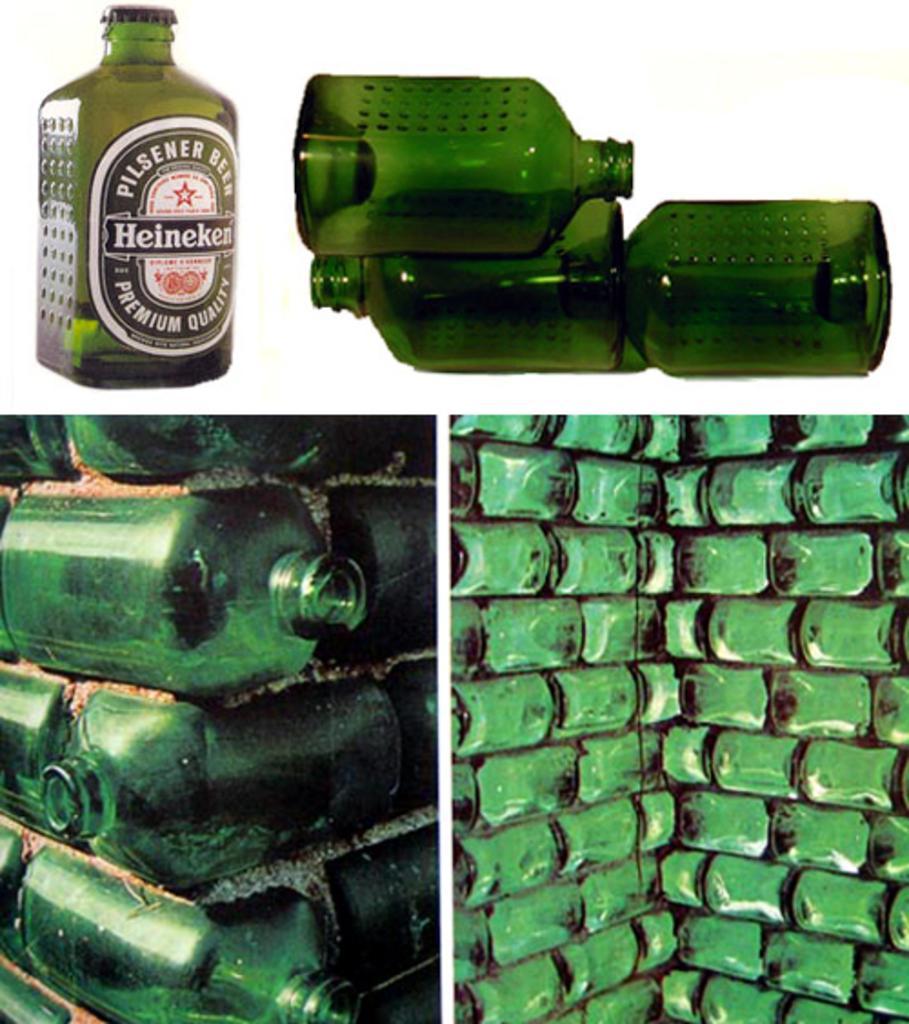How would you summarize this image in a sentence or two? In this image I see collage of pics, in which there are number of green bottles. 